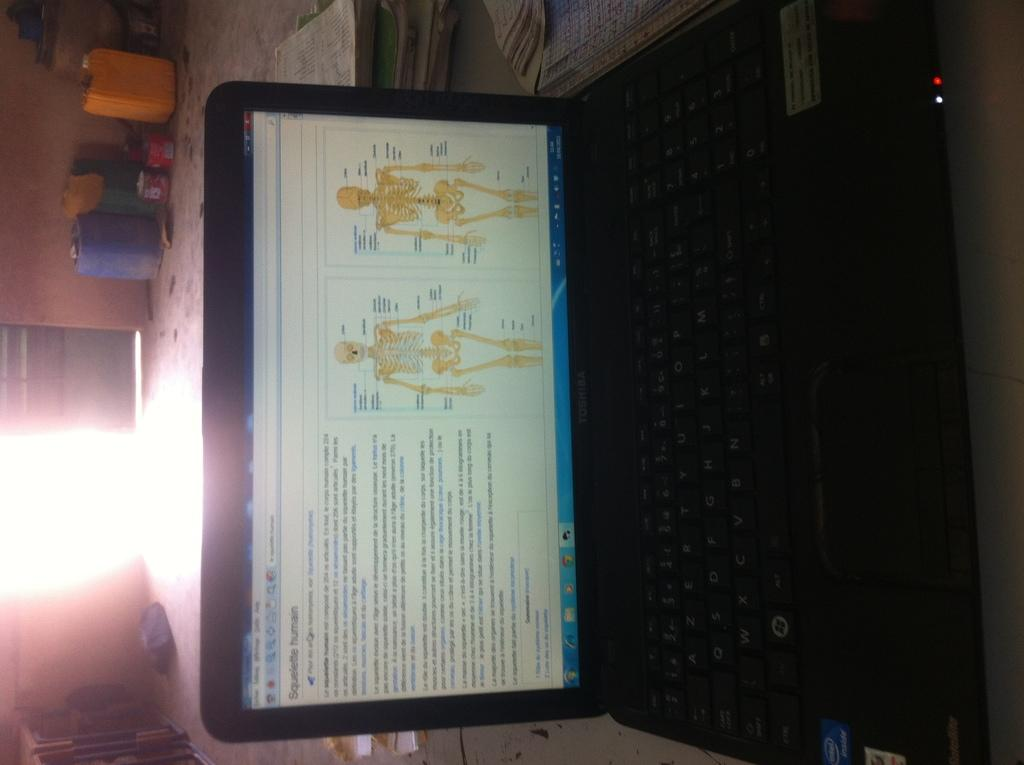What is placed on the table in the image? There is a laptop on a table in the image. What is displayed on the laptop screen? Something is written on the laptop screen, and there are skeletons visible on it. What else can be seen on the table? There are books, a light, and other items on the table. What type of amusement can be seen on the sofa in the image? There is no sofa present in the image, and therefore no amusement can be seen on it. 